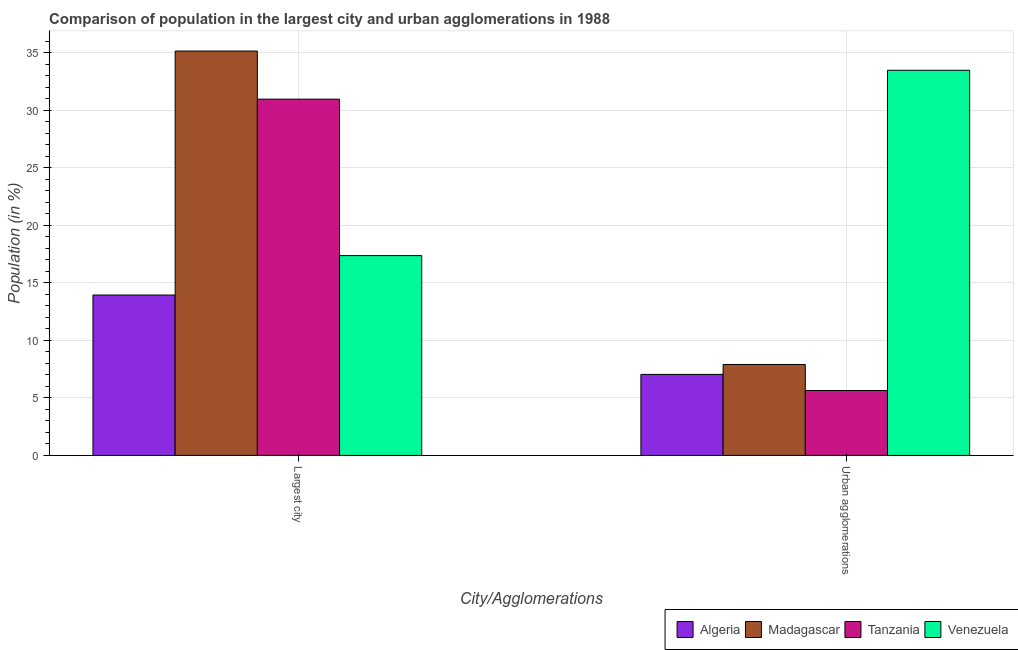How many different coloured bars are there?
Your answer should be compact. 4. Are the number of bars per tick equal to the number of legend labels?
Provide a succinct answer. Yes. How many bars are there on the 2nd tick from the right?
Provide a short and direct response. 4. What is the label of the 1st group of bars from the left?
Your answer should be compact. Largest city. What is the population in urban agglomerations in Algeria?
Provide a short and direct response. 7.04. Across all countries, what is the maximum population in urban agglomerations?
Offer a very short reply. 33.46. Across all countries, what is the minimum population in the largest city?
Provide a succinct answer. 13.94. In which country was the population in urban agglomerations maximum?
Give a very brief answer. Venezuela. In which country was the population in the largest city minimum?
Your answer should be compact. Algeria. What is the total population in the largest city in the graph?
Offer a very short reply. 97.38. What is the difference between the population in urban agglomerations in Venezuela and that in Madagascar?
Make the answer very short. 25.56. What is the difference between the population in urban agglomerations in Madagascar and the population in the largest city in Tanzania?
Your answer should be very brief. -23.05. What is the average population in urban agglomerations per country?
Offer a very short reply. 13.51. What is the difference between the population in urban agglomerations and population in the largest city in Tanzania?
Ensure brevity in your answer.  -25.31. In how many countries, is the population in the largest city greater than 12 %?
Offer a very short reply. 4. What is the ratio of the population in urban agglomerations in Madagascar to that in Algeria?
Provide a succinct answer. 1.12. In how many countries, is the population in the largest city greater than the average population in the largest city taken over all countries?
Your answer should be very brief. 2. What does the 1st bar from the left in Largest city represents?
Your response must be concise. Algeria. What does the 2nd bar from the right in Largest city represents?
Keep it short and to the point. Tanzania. Are the values on the major ticks of Y-axis written in scientific E-notation?
Ensure brevity in your answer.  No. Does the graph contain any zero values?
Provide a succinct answer. No. Does the graph contain grids?
Your answer should be very brief. Yes. How are the legend labels stacked?
Offer a very short reply. Horizontal. What is the title of the graph?
Keep it short and to the point. Comparison of population in the largest city and urban agglomerations in 1988. Does "Albania" appear as one of the legend labels in the graph?
Provide a short and direct response. No. What is the label or title of the X-axis?
Your answer should be very brief. City/Agglomerations. What is the Population (in %) of Algeria in Largest city?
Keep it short and to the point. 13.94. What is the Population (in %) of Madagascar in Largest city?
Offer a terse response. 35.13. What is the Population (in %) in Tanzania in Largest city?
Your answer should be very brief. 30.95. What is the Population (in %) of Venezuela in Largest city?
Make the answer very short. 17.36. What is the Population (in %) in Algeria in Urban agglomerations?
Provide a short and direct response. 7.04. What is the Population (in %) of Madagascar in Urban agglomerations?
Provide a succinct answer. 7.9. What is the Population (in %) in Tanzania in Urban agglomerations?
Your answer should be compact. 5.64. What is the Population (in %) of Venezuela in Urban agglomerations?
Keep it short and to the point. 33.46. Across all City/Agglomerations, what is the maximum Population (in %) of Algeria?
Make the answer very short. 13.94. Across all City/Agglomerations, what is the maximum Population (in %) of Madagascar?
Make the answer very short. 35.13. Across all City/Agglomerations, what is the maximum Population (in %) in Tanzania?
Give a very brief answer. 30.95. Across all City/Agglomerations, what is the maximum Population (in %) of Venezuela?
Offer a terse response. 33.46. Across all City/Agglomerations, what is the minimum Population (in %) in Algeria?
Make the answer very short. 7.04. Across all City/Agglomerations, what is the minimum Population (in %) of Madagascar?
Give a very brief answer. 7.9. Across all City/Agglomerations, what is the minimum Population (in %) of Tanzania?
Provide a short and direct response. 5.64. Across all City/Agglomerations, what is the minimum Population (in %) of Venezuela?
Your response must be concise. 17.36. What is the total Population (in %) in Algeria in the graph?
Ensure brevity in your answer.  20.98. What is the total Population (in %) in Madagascar in the graph?
Your answer should be compact. 43.03. What is the total Population (in %) in Tanzania in the graph?
Keep it short and to the point. 36.59. What is the total Population (in %) of Venezuela in the graph?
Your answer should be very brief. 50.82. What is the difference between the Population (in %) of Algeria in Largest city and that in Urban agglomerations?
Provide a short and direct response. 6.9. What is the difference between the Population (in %) in Madagascar in Largest city and that in Urban agglomerations?
Your response must be concise. 27.23. What is the difference between the Population (in %) in Tanzania in Largest city and that in Urban agglomerations?
Make the answer very short. 25.31. What is the difference between the Population (in %) of Venezuela in Largest city and that in Urban agglomerations?
Provide a succinct answer. -16.1. What is the difference between the Population (in %) in Algeria in Largest city and the Population (in %) in Madagascar in Urban agglomerations?
Provide a short and direct response. 6.04. What is the difference between the Population (in %) of Algeria in Largest city and the Population (in %) of Tanzania in Urban agglomerations?
Give a very brief answer. 8.3. What is the difference between the Population (in %) in Algeria in Largest city and the Population (in %) in Venezuela in Urban agglomerations?
Your answer should be compact. -19.53. What is the difference between the Population (in %) in Madagascar in Largest city and the Population (in %) in Tanzania in Urban agglomerations?
Your answer should be very brief. 29.49. What is the difference between the Population (in %) in Madagascar in Largest city and the Population (in %) in Venezuela in Urban agglomerations?
Keep it short and to the point. 1.67. What is the difference between the Population (in %) of Tanzania in Largest city and the Population (in %) of Venezuela in Urban agglomerations?
Provide a succinct answer. -2.51. What is the average Population (in %) in Algeria per City/Agglomerations?
Ensure brevity in your answer.  10.49. What is the average Population (in %) of Madagascar per City/Agglomerations?
Give a very brief answer. 21.52. What is the average Population (in %) in Tanzania per City/Agglomerations?
Offer a very short reply. 18.3. What is the average Population (in %) in Venezuela per City/Agglomerations?
Your response must be concise. 25.41. What is the difference between the Population (in %) of Algeria and Population (in %) of Madagascar in Largest city?
Provide a succinct answer. -21.2. What is the difference between the Population (in %) in Algeria and Population (in %) in Tanzania in Largest city?
Your response must be concise. -17.02. What is the difference between the Population (in %) in Algeria and Population (in %) in Venezuela in Largest city?
Your answer should be very brief. -3.42. What is the difference between the Population (in %) of Madagascar and Population (in %) of Tanzania in Largest city?
Ensure brevity in your answer.  4.18. What is the difference between the Population (in %) in Madagascar and Population (in %) in Venezuela in Largest city?
Keep it short and to the point. 17.77. What is the difference between the Population (in %) in Tanzania and Population (in %) in Venezuela in Largest city?
Offer a terse response. 13.59. What is the difference between the Population (in %) of Algeria and Population (in %) of Madagascar in Urban agglomerations?
Your answer should be compact. -0.86. What is the difference between the Population (in %) of Algeria and Population (in %) of Tanzania in Urban agglomerations?
Provide a short and direct response. 1.4. What is the difference between the Population (in %) in Algeria and Population (in %) in Venezuela in Urban agglomerations?
Your answer should be very brief. -26.42. What is the difference between the Population (in %) of Madagascar and Population (in %) of Tanzania in Urban agglomerations?
Provide a short and direct response. 2.26. What is the difference between the Population (in %) of Madagascar and Population (in %) of Venezuela in Urban agglomerations?
Keep it short and to the point. -25.56. What is the difference between the Population (in %) of Tanzania and Population (in %) of Venezuela in Urban agglomerations?
Give a very brief answer. -27.82. What is the ratio of the Population (in %) of Algeria in Largest city to that in Urban agglomerations?
Ensure brevity in your answer.  1.98. What is the ratio of the Population (in %) in Madagascar in Largest city to that in Urban agglomerations?
Make the answer very short. 4.45. What is the ratio of the Population (in %) of Tanzania in Largest city to that in Urban agglomerations?
Your answer should be compact. 5.49. What is the ratio of the Population (in %) of Venezuela in Largest city to that in Urban agglomerations?
Make the answer very short. 0.52. What is the difference between the highest and the second highest Population (in %) of Algeria?
Provide a short and direct response. 6.9. What is the difference between the highest and the second highest Population (in %) of Madagascar?
Give a very brief answer. 27.23. What is the difference between the highest and the second highest Population (in %) in Tanzania?
Offer a very short reply. 25.31. What is the difference between the highest and the second highest Population (in %) in Venezuela?
Keep it short and to the point. 16.1. What is the difference between the highest and the lowest Population (in %) in Algeria?
Your answer should be very brief. 6.9. What is the difference between the highest and the lowest Population (in %) in Madagascar?
Give a very brief answer. 27.23. What is the difference between the highest and the lowest Population (in %) in Tanzania?
Offer a very short reply. 25.31. What is the difference between the highest and the lowest Population (in %) in Venezuela?
Provide a short and direct response. 16.1. 